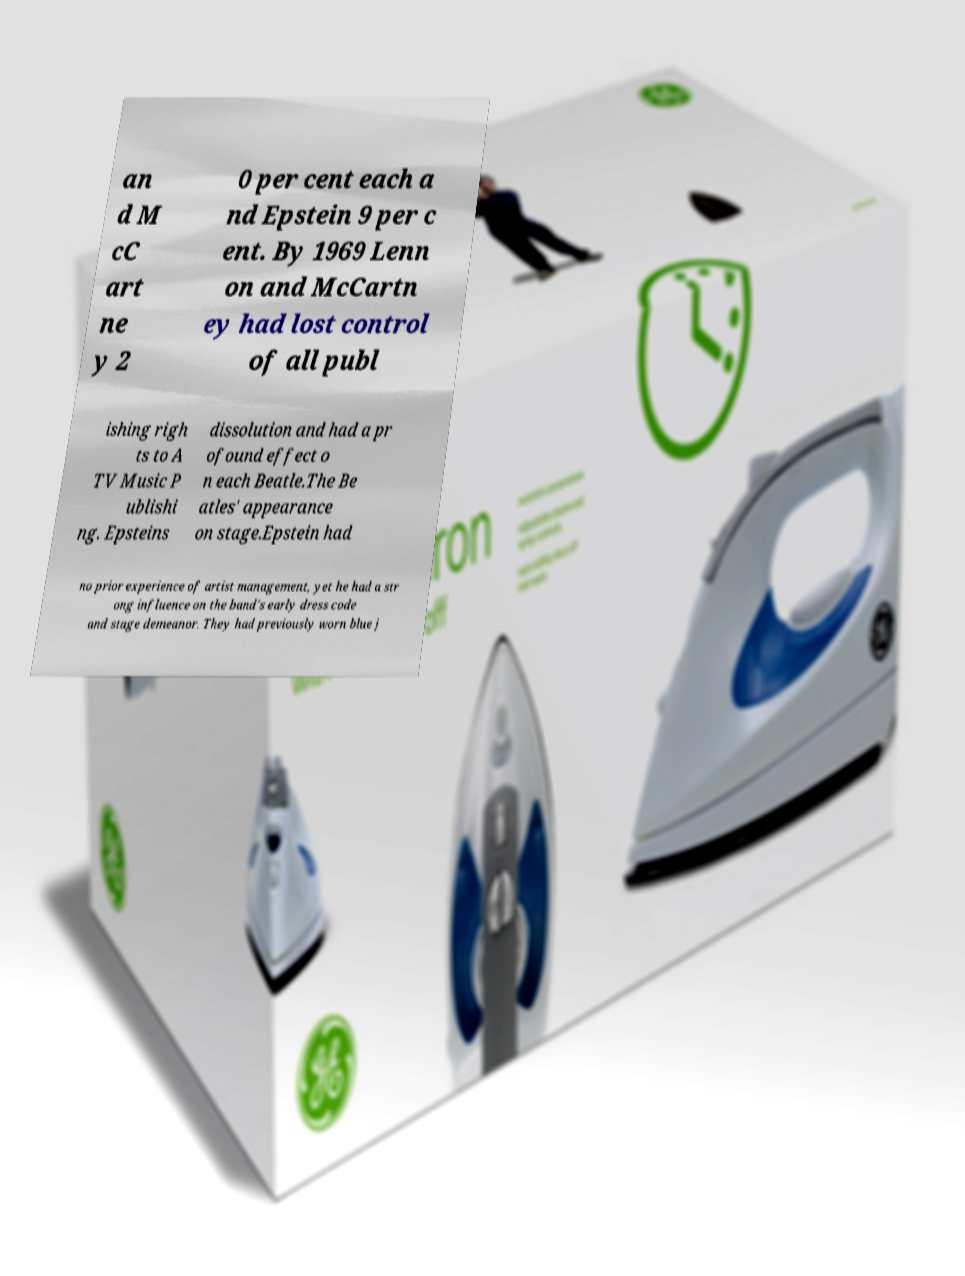Please read and relay the text visible in this image. What does it say? an d M cC art ne y 2 0 per cent each a nd Epstein 9 per c ent. By 1969 Lenn on and McCartn ey had lost control of all publ ishing righ ts to A TV Music P ublishi ng. Epsteins dissolution and had a pr ofound effect o n each Beatle.The Be atles' appearance on stage.Epstein had no prior experience of artist management, yet he had a str ong influence on the band's early dress code and stage demeanor. They had previously worn blue j 